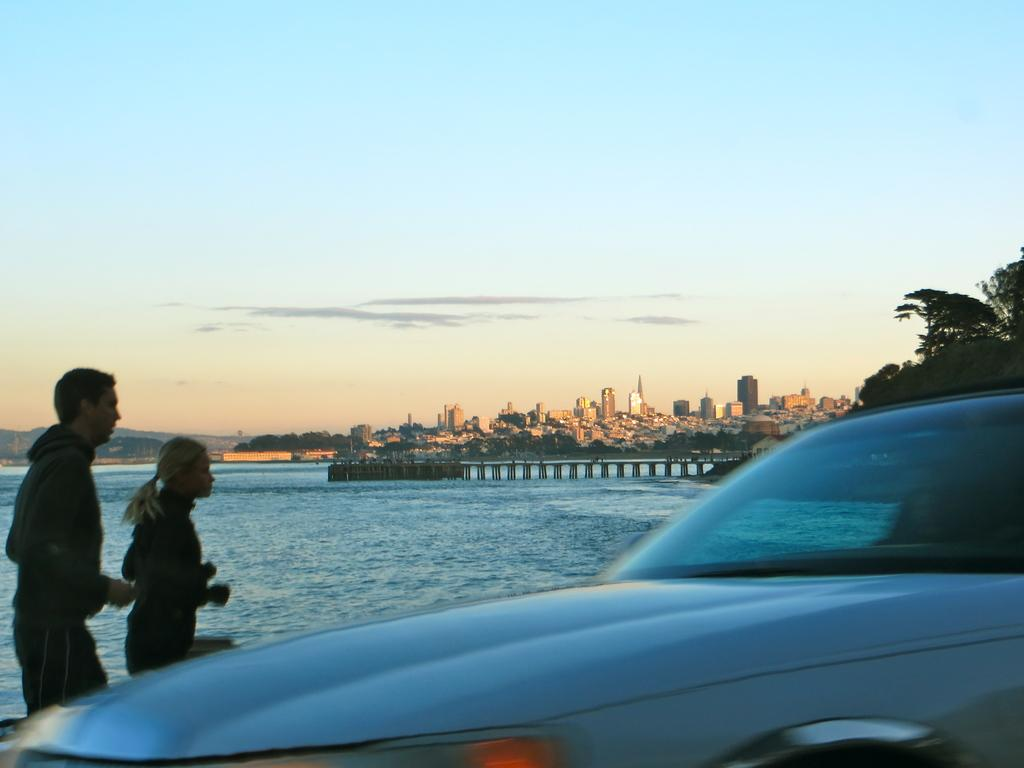What is the main subject in the image? There is a car in the image. What are the two people in the image doing? They are running in the image. What natural element can be seen in the image? There is water visible in the image. What type of vegetation is present in the image? There are trees in the image. What man-made structures can be seen in the image? There are buildings in the image. What type of cup is being used to express anger in the image? There is no cup or expression of anger present in the image. 